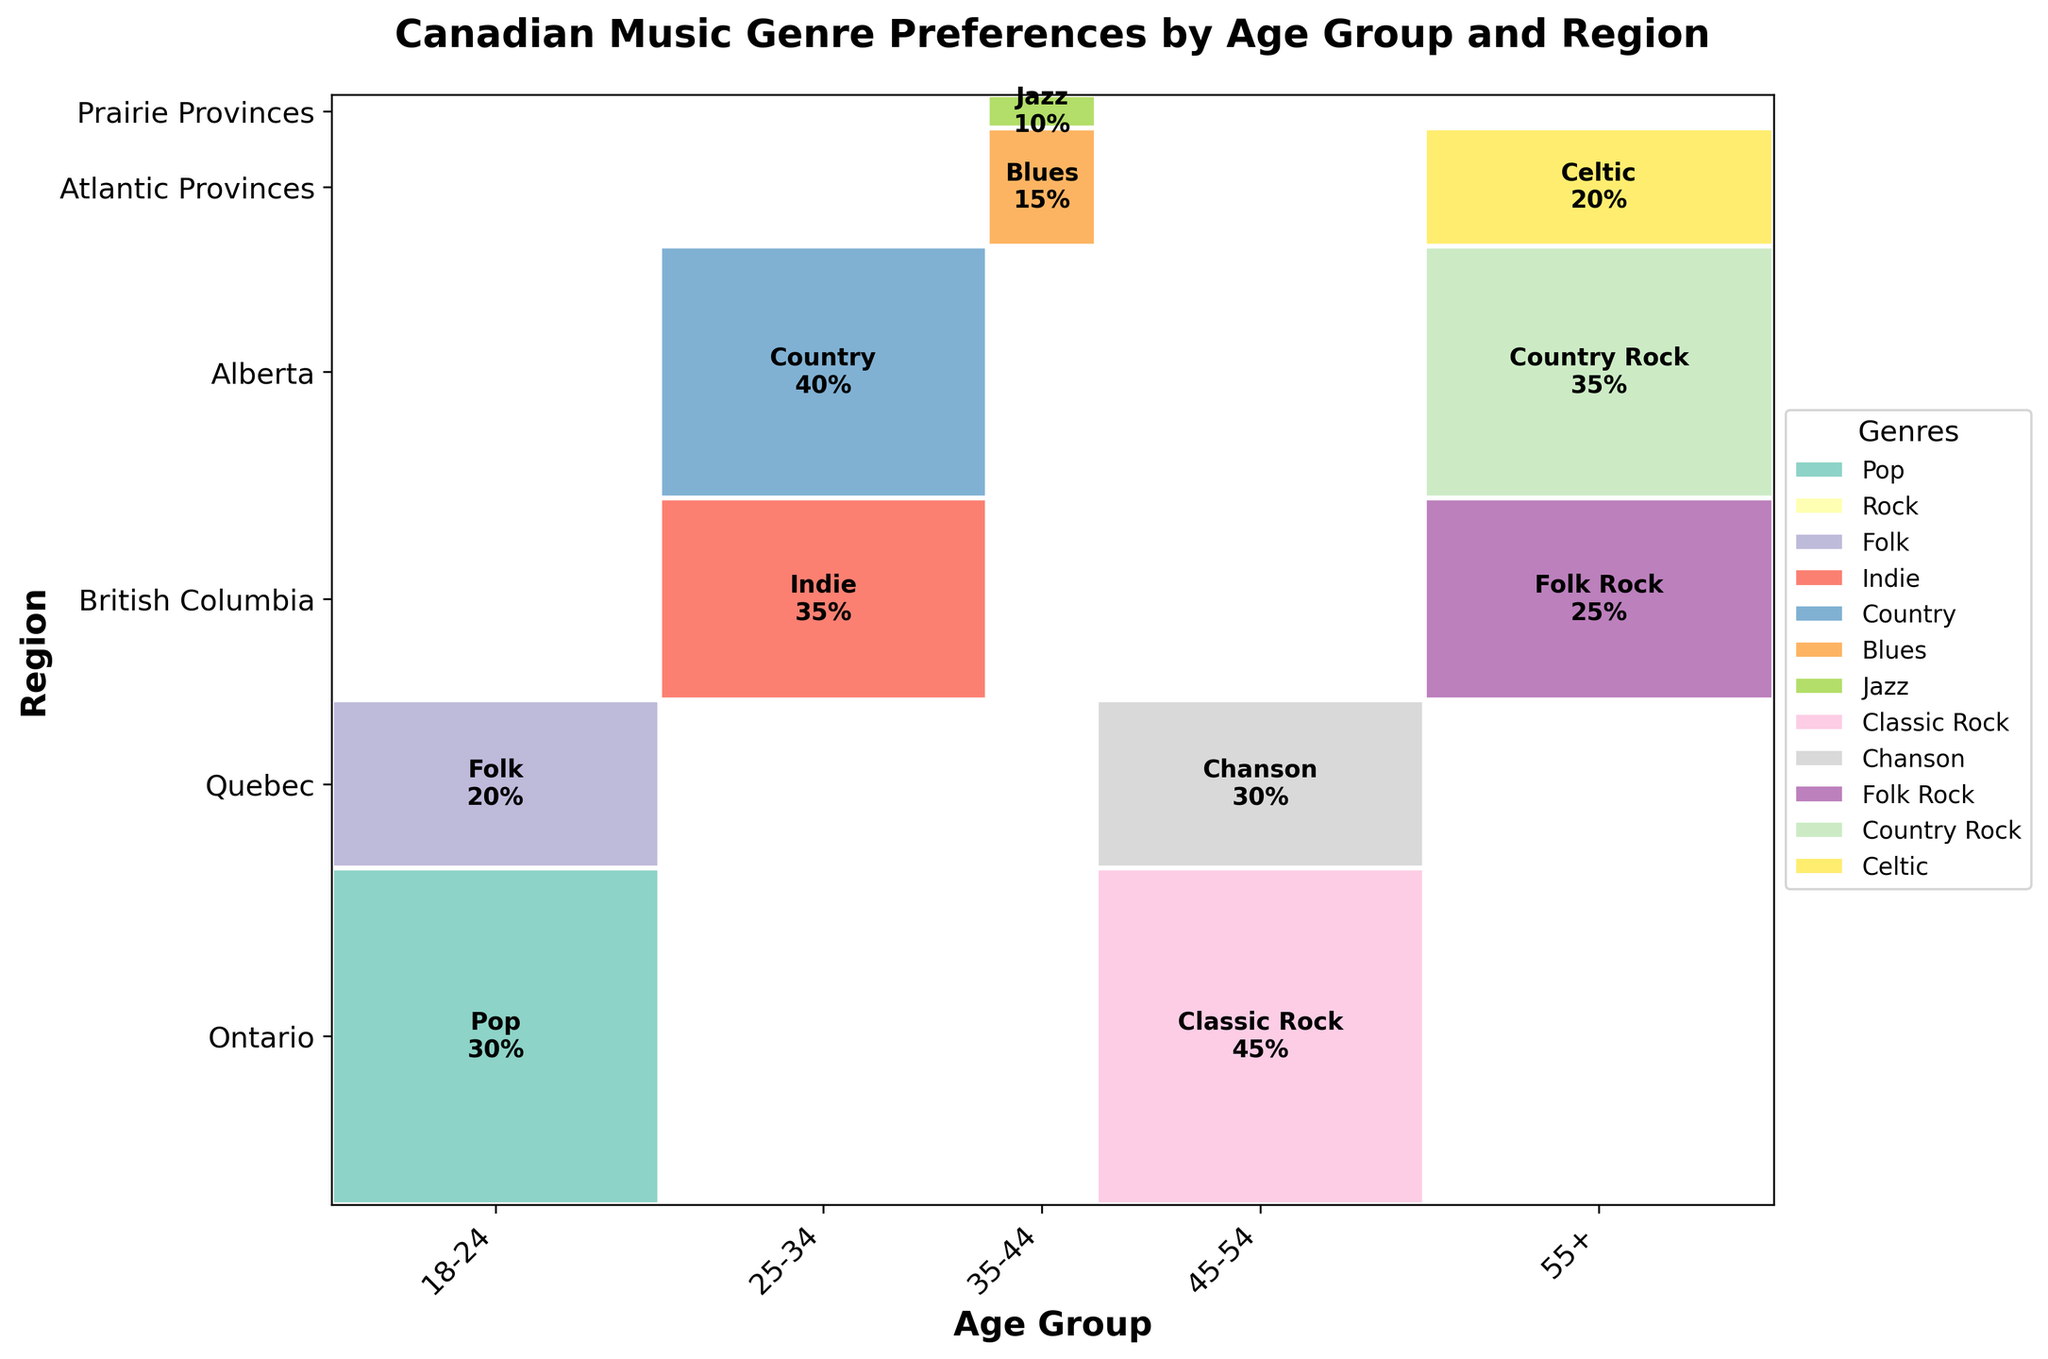What is the most popular genre among the 25-34 age group in Alberta? Look at the section of the mosaic plot corresponding to the 25-34 age group and Alberta region. The label indicates that the genre is Country with a 40% share.
Answer: Country What genre is preferred by people aged 45-54 in Ontario? Examine the section of the mosaic plot for the 45-54 age group and Ontario region. The genre label in this area is Classic Rock, with a 45% share.
Answer: Classic Rock Which age group has the highest preference for Indie music in British Columbia? Check for any sections where Indie music is labeled in British Columbia. The label for the Indie genre appears in the 25-34 age group section, marked as 35%.
Answer: 25-34 How does the percentage of Folk music in Quebec for the 18-24 age group compare to the percentage of Chanson for the 45-54 age group in Quebec? Locate the section for the 18-24 age group in Quebec, finding a 20% share for Folk. Then, locate the 45-54 age group in Quebec, which shows a 30% share for Chanson. Folk has a smaller share (20%) compared to Chanson (30%).
Answer: Less by 10% What is the most popular genre in the Atlantic Provinces for the 55+ age group? Identify the section for the 55+ age group in the Atlantic Provinces region. The label indicates the genre is Celtic with a 20% share.
Answer: Celtic Which genre is more popular in Alberta for the 55+ age group: Country Rock or in British Columbia for the same age group: Folk Rock? Find the sections for the 55+ age group in Alberta and British Columbia. Alberta shows Country Rock with a 35% share, while British Columbia shows Folk Rock with a 25% share. Country Rock is more popular with a higher percentage.
Answer: Country Rock What is the total percentage of genres preferred by the age group 18-24 in Ontario? Sum the percentages for the 18-24 age group in Ontario. Pop is 30% and Rock is 25%. Adding them gives 30% + 25% = 55%.
Answer: 55% Which region has the highest percentage preference for a Country-related genre? Check for the highest indicated percentages among regions having Country or Country Rock. Alberta, both in the 25-34 age group (Country 40%) and the 55+ age group (Country Rock 35%), has the highest share. Selecting the highest of these, Alberta's 25-34 group has 40%.
Answer: Alberta What genre is shown for the Jazz category and in which region and age group does it fall? Locate the Jazz genre by examining the labels within the mosaic plot's squares. Jazz appears in the Prairie Provinces for the 35-44 age group, marked at 10%.
Answer: Prairie Provinces, 35-44 What is the combined percentage preference for genres in Quebec for all age groups? Sum the percentages for all genres in Quebec: 18-24 (Folk 20%) and 45-54 (Chanson 30%). Adding them gives 20% + 30% = 50%.
Answer: 50% 